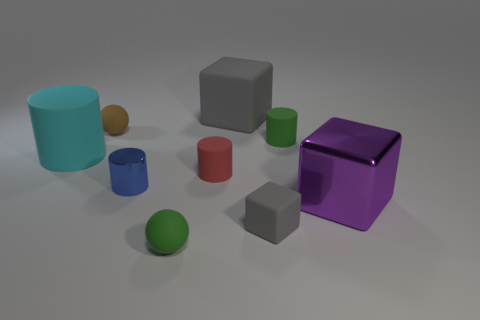Subtract 1 cylinders. How many cylinders are left? 3 Add 1 rubber cylinders. How many objects exist? 10 Subtract all spheres. How many objects are left? 7 Add 4 large red metal cylinders. How many large red metal cylinders exist? 4 Subtract 0 purple cylinders. How many objects are left? 9 Subtract all tiny blue rubber spheres. Subtract all purple things. How many objects are left? 8 Add 1 large objects. How many large objects are left? 4 